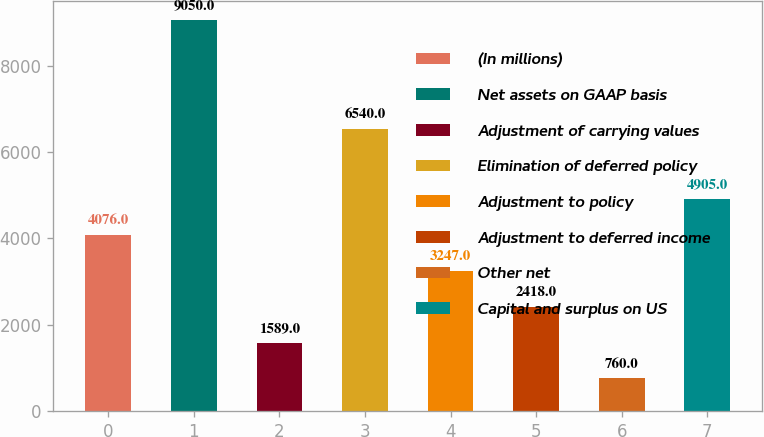Convert chart. <chart><loc_0><loc_0><loc_500><loc_500><bar_chart><fcel>(In millions)<fcel>Net assets on GAAP basis<fcel>Adjustment of carrying values<fcel>Elimination of deferred policy<fcel>Adjustment to policy<fcel>Adjustment to deferred income<fcel>Other net<fcel>Capital and surplus on US<nl><fcel>4076<fcel>9050<fcel>1589<fcel>6540<fcel>3247<fcel>2418<fcel>760<fcel>4905<nl></chart> 